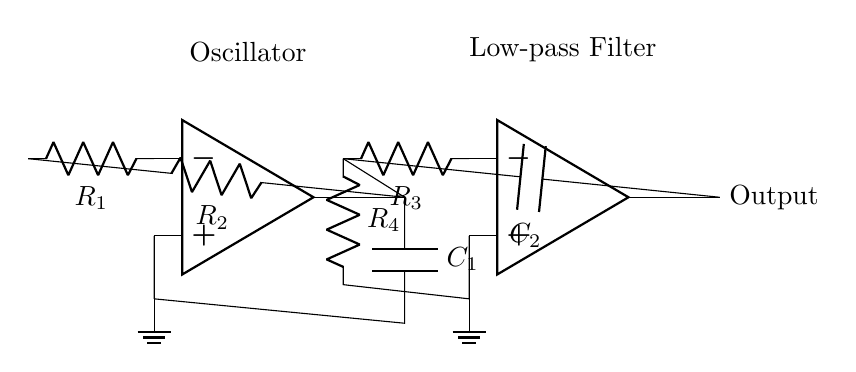What is the type of circuit depicted? The circuit is an oscillator combined with a low-pass filter. The presence of an operational amplifier (op amp) in both sections signifies their roles in signal generation and modification.
Answer: oscillator and low-pass filter How many resistors are in the circuit? There are four resistors labeled R1, R2, R3, and R4, which are diverse components frequently used in electronic circuits for current regulation and voltage division.
Answer: four What is the capacitor value in the oscillator section? The capacitor in the oscillator section is labeled C1, indicating its role in determining the oscillator's frequency. The visual representation does not display a specific value, but it is a critical component for oscillation.
Answer: C1 What is the connection between the oscillator and filter? The oscillator output is directly connected to the input of the low-pass filter, allowing the generated signal to be processed by the filter section. This connection facilitates the modification of the signal frequency characteristic.
Answer: direct connection What is the purpose of R4 in this circuit? Resistor R4 is part of the low-pass filter and is responsible for shaping the frequency response by determining the cutoff frequency when paired with the capacitor. This functions in conjunction with R3 for tuning purposes.
Answer: shaping frequency response How does the capacitor affect the oscillator frequency? The capacitor C1 in the oscillator setup, along with resistors R1 and R2, establishes an RC time constant that influences the frequency of oscillation. The capacitance plays a direct role in controlling how quickly the charge and discharge occurs, thereby determining the oscillation rate.
Answer: establishes frequency What would happen if the value of R2 is increased? Increasing R2 would generally lower the frequency of the oscillator, as it affects the RC time constant, resulting in a longer time for the capacitor to charge and discharge. This relationship shows R2's significant effect on oscillation behavior.
Answer: lower frequency 